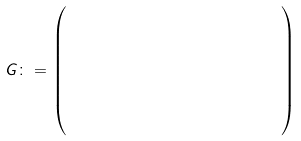<formula> <loc_0><loc_0><loc_500><loc_500>G \colon = \begin{pmatrix} 1 & 0 & 1 & 0 & 1 & 0 & 1 \\ 0 & 1 & 1 & 0 & 0 & 1 & 1 \\ 0 & 0 & 0 & 1 & 1 & 1 & 1 \\ 1 & 1 & 1 & 0 & 0 & 0 & 0 \end{pmatrix}</formula> 